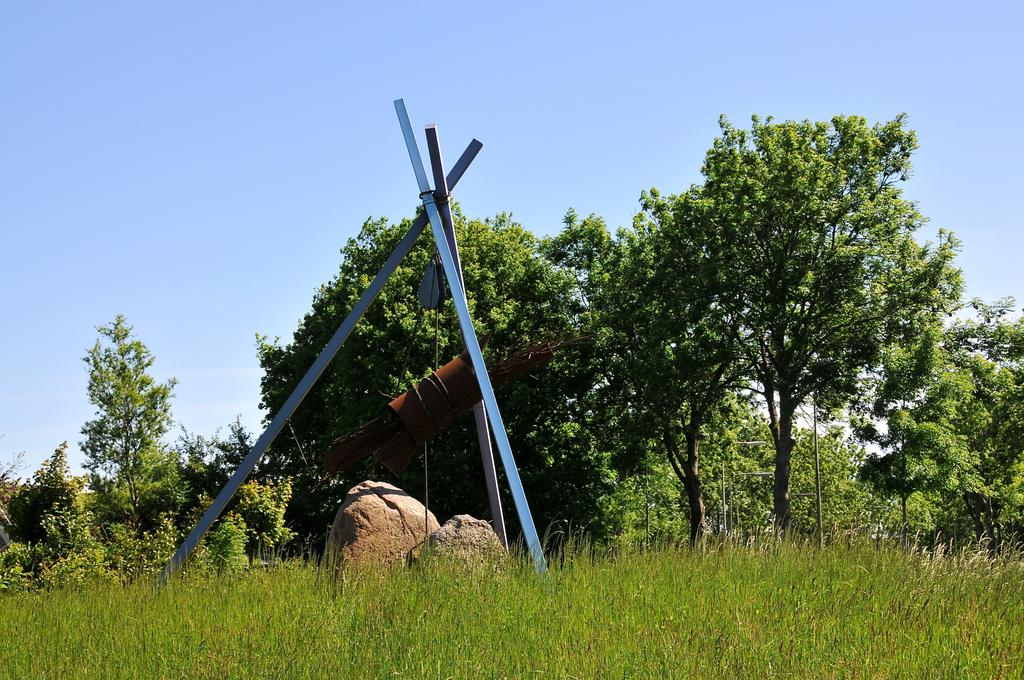What type of vegetation can be seen in the image? There is grass in the image. What other objects can be seen in the image? There are rocks and an object tied to the poles. What can be seen in the background of the image? There are plants, trees, poles, and the sky visible in the background of the image. What type of wine is being served in the image? There is no wine present in the image; it features grass, rocks, an object tied to poles, and a background with plants, trees, poles, and the sky. 